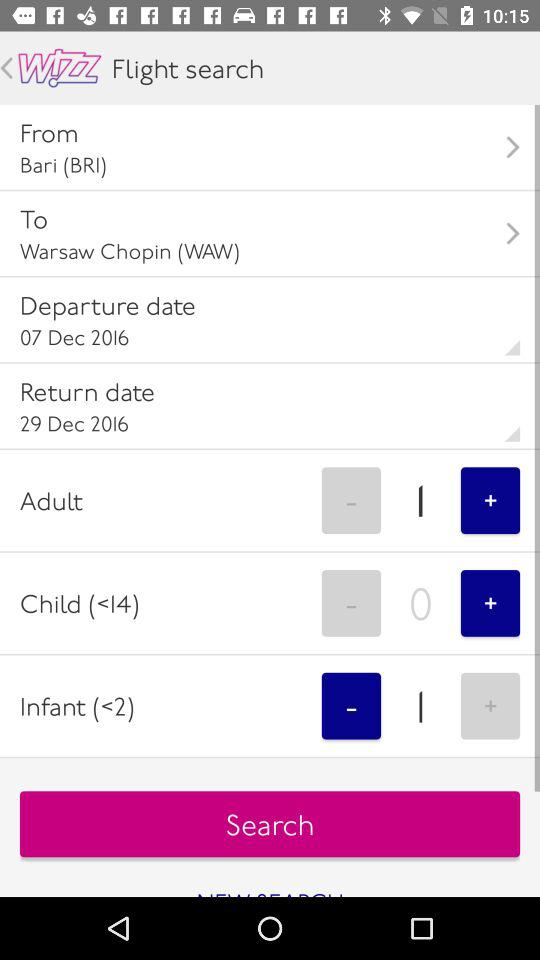What is the return date? The return date is December 29, 2016. 